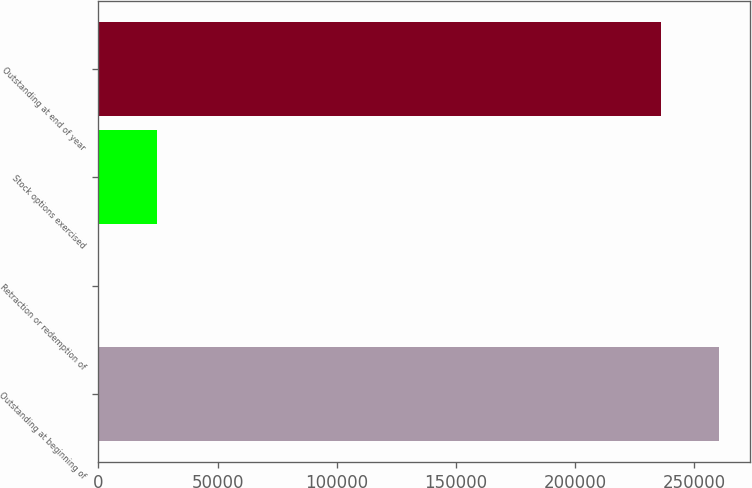<chart> <loc_0><loc_0><loc_500><loc_500><bar_chart><fcel>Outstanding at beginning of<fcel>Retraction or redemption of<fcel>Stock options exercised<fcel>Outstanding at end of year<nl><fcel>260328<fcel>57<fcel>24365.1<fcel>236020<nl></chart> 